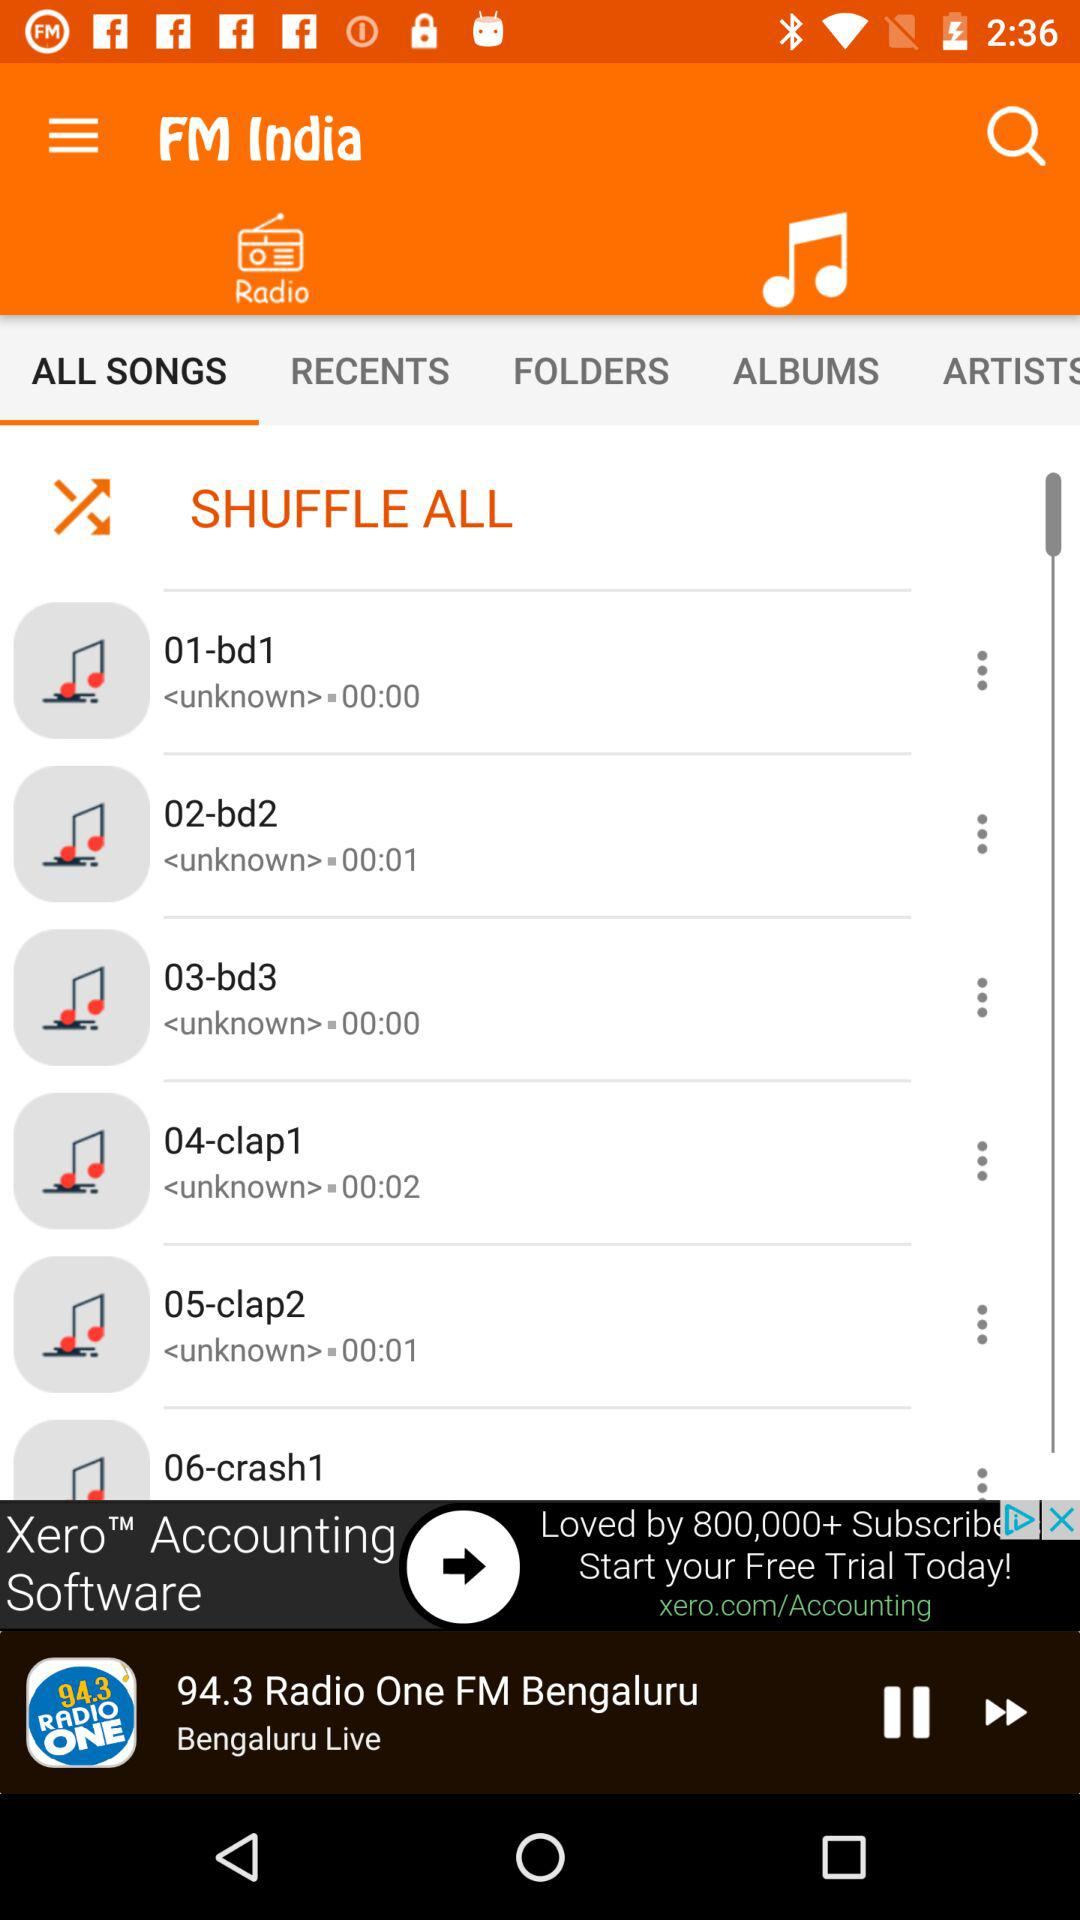Which radio channel is playing now? The radio channel "94.3 Radio One FM" is playing now. 